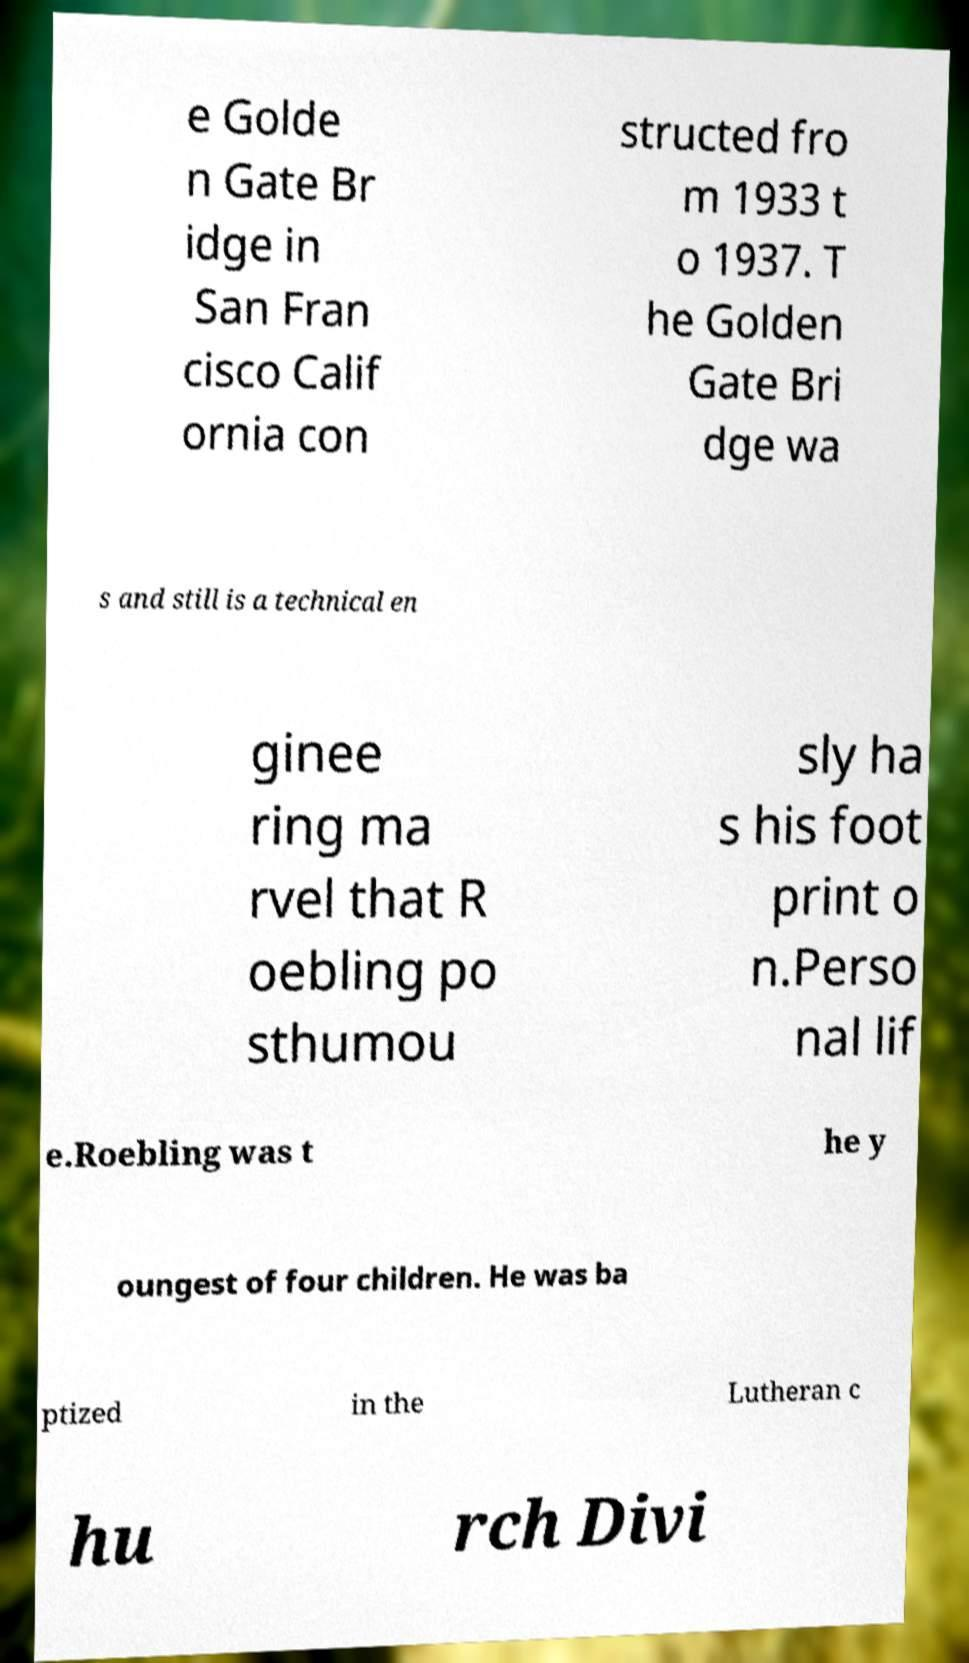Please identify and transcribe the text found in this image. e Golde n Gate Br idge in San Fran cisco Calif ornia con structed fro m 1933 t o 1937. T he Golden Gate Bri dge wa s and still is a technical en ginee ring ma rvel that R oebling po sthumou sly ha s his foot print o n.Perso nal lif e.Roebling was t he y oungest of four children. He was ba ptized in the Lutheran c hu rch Divi 